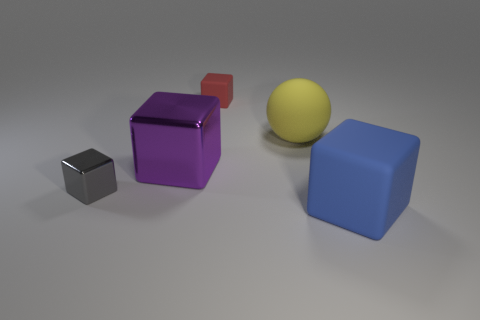Add 4 cyan shiny balls. How many objects exist? 9 Subtract all blocks. How many objects are left? 1 Subtract all brown cubes. Subtract all tiny shiny cubes. How many objects are left? 4 Add 5 small metal cubes. How many small metal cubes are left? 6 Add 5 rubber spheres. How many rubber spheres exist? 6 Subtract 0 yellow cubes. How many objects are left? 5 